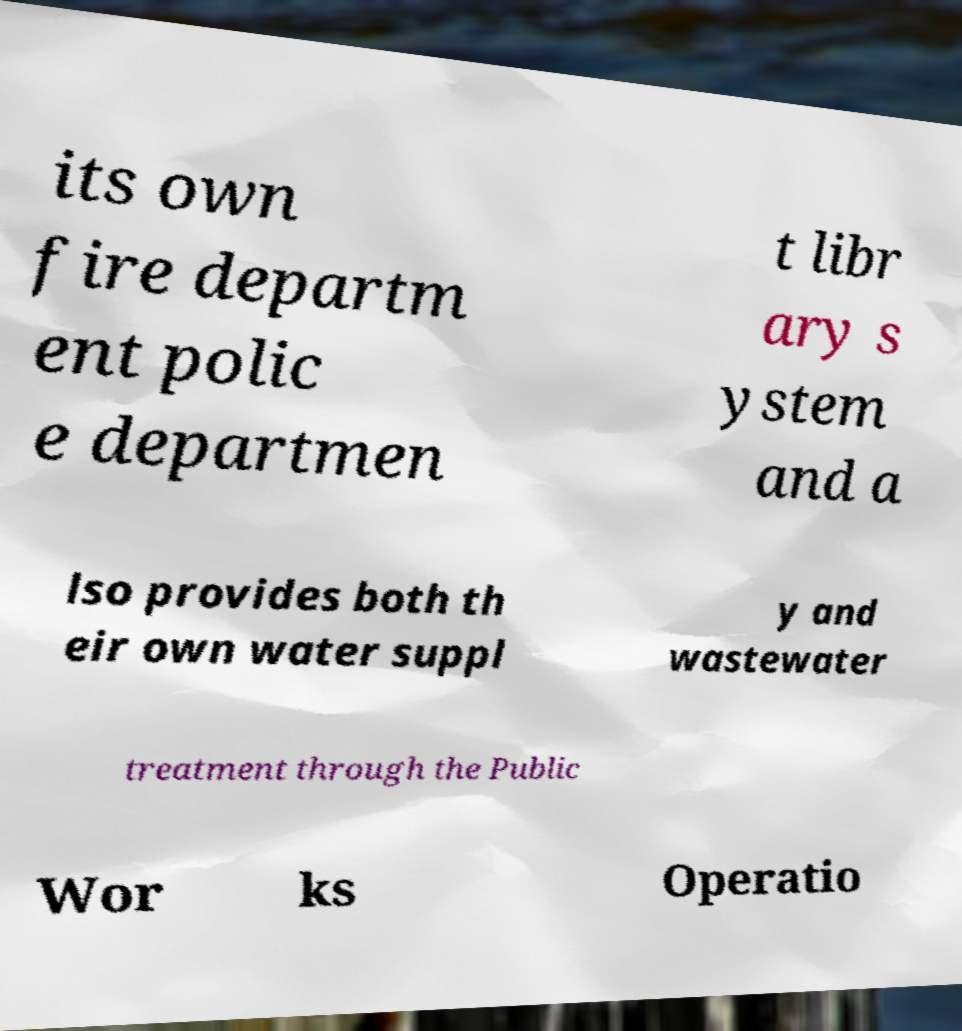Please read and relay the text visible in this image. What does it say? its own fire departm ent polic e departmen t libr ary s ystem and a lso provides both th eir own water suppl y and wastewater treatment through the Public Wor ks Operatio 